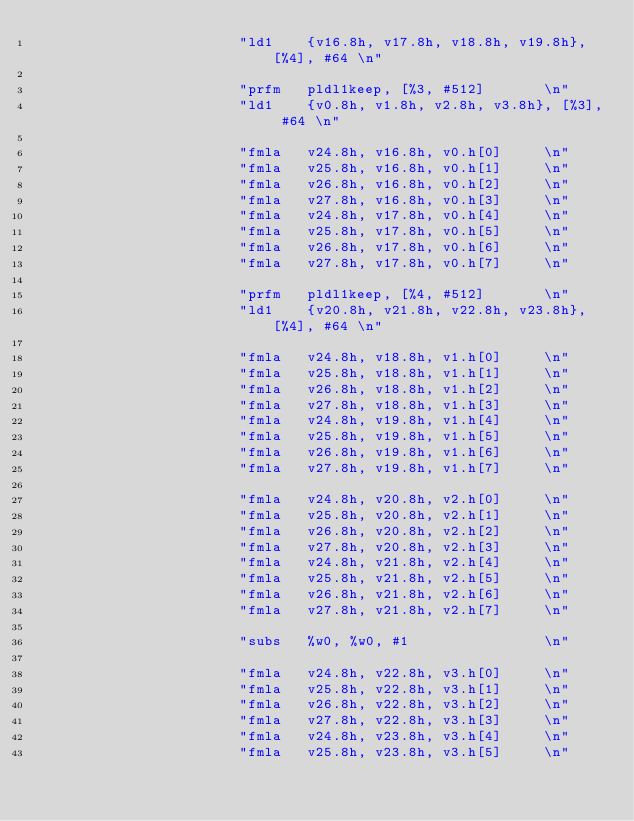Convert code to text. <code><loc_0><loc_0><loc_500><loc_500><_C_>                        "ld1    {v16.8h, v17.8h, v18.8h, v19.8h}, [%4], #64 \n"

                        "prfm   pldl1keep, [%3, #512]       \n"
                        "ld1    {v0.8h, v1.8h, v2.8h, v3.8h}, [%3], #64 \n"

                        "fmla   v24.8h, v16.8h, v0.h[0]     \n"
                        "fmla   v25.8h, v16.8h, v0.h[1]     \n"
                        "fmla   v26.8h, v16.8h, v0.h[2]     \n"
                        "fmla   v27.8h, v16.8h, v0.h[3]     \n"
                        "fmla   v24.8h, v17.8h, v0.h[4]     \n"
                        "fmla   v25.8h, v17.8h, v0.h[5]     \n"
                        "fmla   v26.8h, v17.8h, v0.h[6]     \n"
                        "fmla   v27.8h, v17.8h, v0.h[7]     \n"

                        "prfm   pldl1keep, [%4, #512]       \n"
                        "ld1    {v20.8h, v21.8h, v22.8h, v23.8h}, [%4], #64 \n"

                        "fmla   v24.8h, v18.8h, v1.h[0]     \n"
                        "fmla   v25.8h, v18.8h, v1.h[1]     \n"
                        "fmla   v26.8h, v18.8h, v1.h[2]     \n"
                        "fmla   v27.8h, v18.8h, v1.h[3]     \n"
                        "fmla   v24.8h, v19.8h, v1.h[4]     \n"
                        "fmla   v25.8h, v19.8h, v1.h[5]     \n"
                        "fmla   v26.8h, v19.8h, v1.h[6]     \n"
                        "fmla   v27.8h, v19.8h, v1.h[7]     \n"

                        "fmla   v24.8h, v20.8h, v2.h[0]     \n"
                        "fmla   v25.8h, v20.8h, v2.h[1]     \n"
                        "fmla   v26.8h, v20.8h, v2.h[2]     \n"
                        "fmla   v27.8h, v20.8h, v2.h[3]     \n"
                        "fmla   v24.8h, v21.8h, v2.h[4]     \n"
                        "fmla   v25.8h, v21.8h, v2.h[5]     \n"
                        "fmla   v26.8h, v21.8h, v2.h[6]     \n"
                        "fmla   v27.8h, v21.8h, v2.h[7]     \n"

                        "subs   %w0, %w0, #1                \n"

                        "fmla   v24.8h, v22.8h, v3.h[0]     \n"
                        "fmla   v25.8h, v22.8h, v3.h[1]     \n"
                        "fmla   v26.8h, v22.8h, v3.h[2]     \n"
                        "fmla   v27.8h, v22.8h, v3.h[3]     \n"
                        "fmla   v24.8h, v23.8h, v3.h[4]     \n"
                        "fmla   v25.8h, v23.8h, v3.h[5]     \n"</code> 